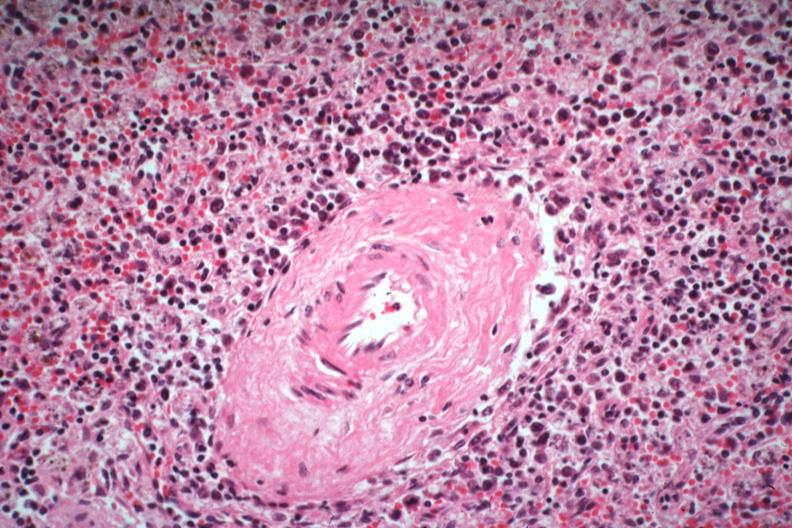s hematologic present?
Answer the question using a single word or phrase. Yes 